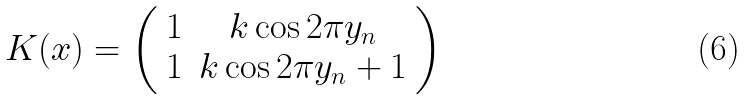Convert formula to latex. <formula><loc_0><loc_0><loc_500><loc_500>K ( x ) = \left ( \begin{array} { c c } 1 & k \cos 2 \pi y _ { n } \\ 1 & k \cos 2 \pi y _ { n } + 1 \end{array} \right )</formula> 